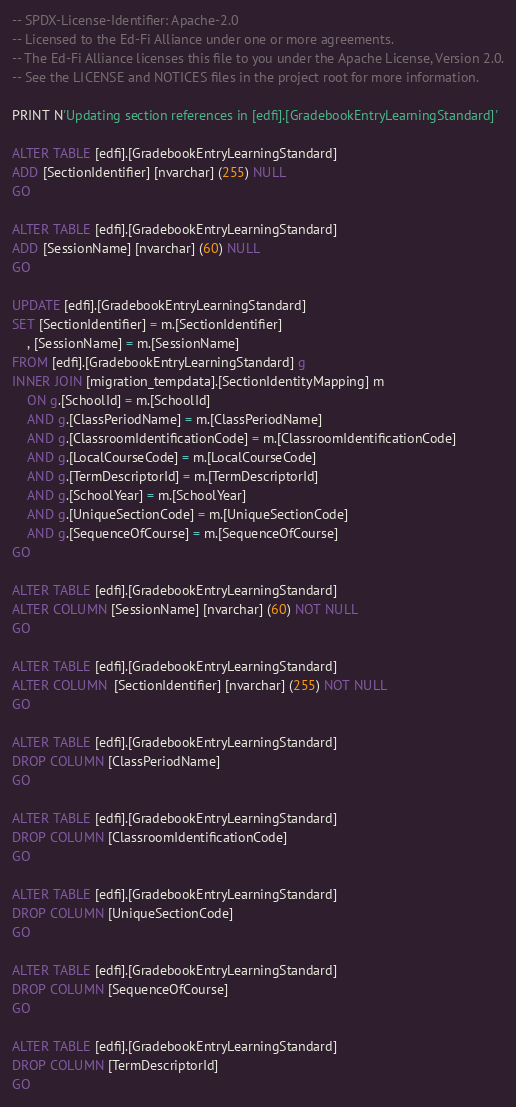<code> <loc_0><loc_0><loc_500><loc_500><_SQL_>-- SPDX-License-Identifier: Apache-2.0
-- Licensed to the Ed-Fi Alliance under one or more agreements.
-- The Ed-Fi Alliance licenses this file to you under the Apache License, Version 2.0.
-- See the LICENSE and NOTICES files in the project root for more information.

PRINT N'Updating section references in [edfi].[GradebookEntryLearningStandard]'

ALTER TABLE [edfi].[GradebookEntryLearningStandard]
ADD [SectionIdentifier] [nvarchar] (255) NULL
GO

ALTER TABLE [edfi].[GradebookEntryLearningStandard]
ADD [SessionName] [nvarchar] (60) NULL
GO

UPDATE [edfi].[GradebookEntryLearningStandard]
SET [SectionIdentifier] = m.[SectionIdentifier]
	, [SessionName] = m.[SessionName]
FROM [edfi].[GradebookEntryLearningStandard] g
INNER JOIN [migration_tempdata].[SectionIdentityMapping] m
	ON g.[SchoolId] = m.[SchoolId]
	AND g.[ClassPeriodName] = m.[ClassPeriodName]
	AND g.[ClassroomIdentificationCode] = m.[ClassroomIdentificationCode]
	AND g.[LocalCourseCode] = m.[LocalCourseCode]
	AND g.[TermDescriptorId] = m.[TermDescriptorId]
	AND g.[SchoolYear] = m.[SchoolYear]
	AND g.[UniqueSectionCode] = m.[UniqueSectionCode]
	AND g.[SequenceOfCourse] = m.[SequenceOfCourse]
GO

ALTER TABLE [edfi].[GradebookEntryLearningStandard]
ALTER COLUMN [SessionName] [nvarchar] (60) NOT NULL
GO

ALTER TABLE [edfi].[GradebookEntryLearningStandard]
ALTER COLUMN  [SectionIdentifier] [nvarchar] (255) NOT NULL
GO

ALTER TABLE [edfi].[GradebookEntryLearningStandard]
DROP COLUMN [ClassPeriodName]
GO

ALTER TABLE [edfi].[GradebookEntryLearningStandard]
DROP COLUMN [ClassroomIdentificationCode]
GO

ALTER TABLE [edfi].[GradebookEntryLearningStandard]
DROP COLUMN [UniqueSectionCode]
GO

ALTER TABLE [edfi].[GradebookEntryLearningStandard]
DROP COLUMN [SequenceOfCourse]
GO

ALTER TABLE [edfi].[GradebookEntryLearningStandard]
DROP COLUMN [TermDescriptorId]
GO
</code> 